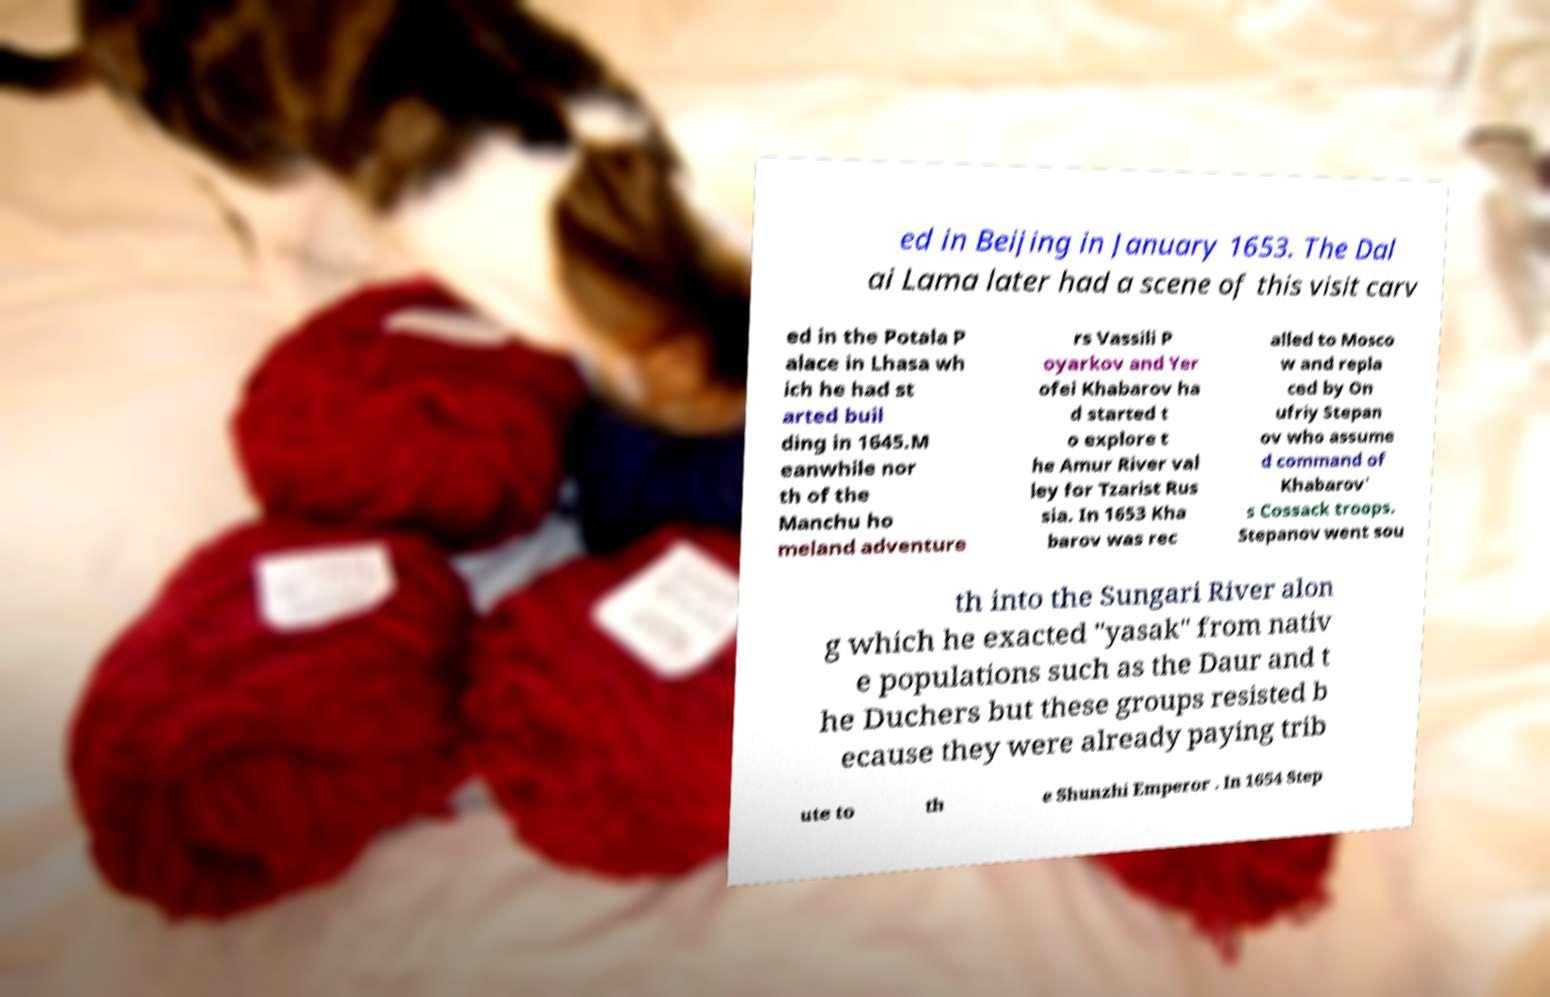Please read and relay the text visible in this image. What does it say? ed in Beijing in January 1653. The Dal ai Lama later had a scene of this visit carv ed in the Potala P alace in Lhasa wh ich he had st arted buil ding in 1645.M eanwhile nor th of the Manchu ho meland adventure rs Vassili P oyarkov and Yer ofei Khabarov ha d started t o explore t he Amur River val ley for Tzarist Rus sia. In 1653 Kha barov was rec alled to Mosco w and repla ced by On ufriy Stepan ov who assume d command of Khabarov' s Cossack troops. Stepanov went sou th into the Sungari River alon g which he exacted "yasak" from nativ e populations such as the Daur and t he Duchers but these groups resisted b ecause they were already paying trib ute to th e Shunzhi Emperor . In 1654 Step 